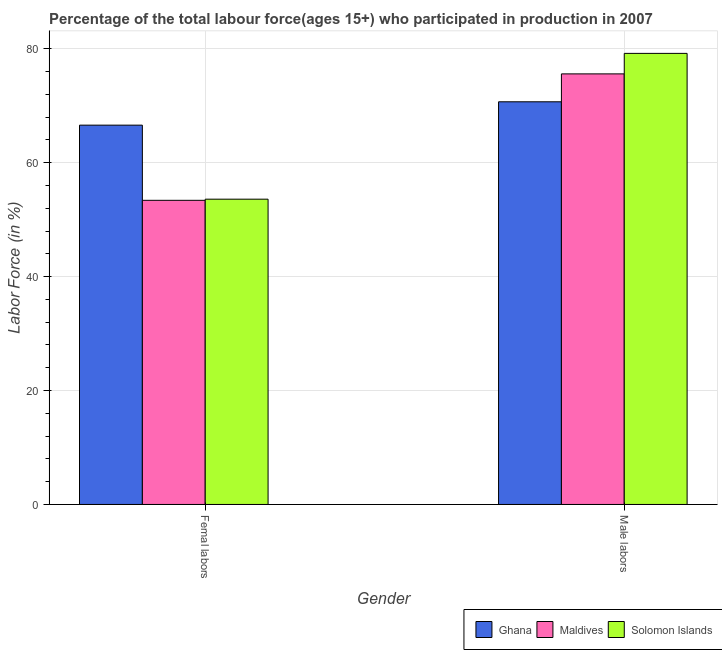Are the number of bars per tick equal to the number of legend labels?
Provide a short and direct response. Yes. How many bars are there on the 2nd tick from the left?
Your response must be concise. 3. What is the label of the 1st group of bars from the left?
Offer a terse response. Femal labors. What is the percentage of male labour force in Solomon Islands?
Your response must be concise. 79.2. Across all countries, what is the maximum percentage of male labour force?
Provide a succinct answer. 79.2. Across all countries, what is the minimum percentage of female labor force?
Your answer should be compact. 53.4. In which country was the percentage of female labor force maximum?
Provide a short and direct response. Ghana. What is the total percentage of male labour force in the graph?
Your response must be concise. 225.5. What is the difference between the percentage of female labor force in Ghana and that in Solomon Islands?
Ensure brevity in your answer.  13. What is the difference between the percentage of male labour force in Ghana and the percentage of female labor force in Maldives?
Provide a short and direct response. 17.3. What is the average percentage of male labour force per country?
Ensure brevity in your answer.  75.17. What is the difference between the percentage of male labour force and percentage of female labor force in Maldives?
Your response must be concise. 22.2. What is the ratio of the percentage of female labor force in Solomon Islands to that in Maldives?
Make the answer very short. 1. In how many countries, is the percentage of female labor force greater than the average percentage of female labor force taken over all countries?
Keep it short and to the point. 1. What does the 2nd bar from the right in Femal labors represents?
Make the answer very short. Maldives. Are all the bars in the graph horizontal?
Ensure brevity in your answer.  No. Does the graph contain grids?
Your response must be concise. Yes. Where does the legend appear in the graph?
Offer a very short reply. Bottom right. How many legend labels are there?
Keep it short and to the point. 3. How are the legend labels stacked?
Ensure brevity in your answer.  Horizontal. What is the title of the graph?
Your answer should be compact. Percentage of the total labour force(ages 15+) who participated in production in 2007. What is the label or title of the X-axis?
Give a very brief answer. Gender. What is the Labor Force (in %) of Ghana in Femal labors?
Your response must be concise. 66.6. What is the Labor Force (in %) of Maldives in Femal labors?
Your answer should be very brief. 53.4. What is the Labor Force (in %) of Solomon Islands in Femal labors?
Your answer should be very brief. 53.6. What is the Labor Force (in %) in Ghana in Male labors?
Provide a short and direct response. 70.7. What is the Labor Force (in %) of Maldives in Male labors?
Your answer should be very brief. 75.6. What is the Labor Force (in %) in Solomon Islands in Male labors?
Make the answer very short. 79.2. Across all Gender, what is the maximum Labor Force (in %) in Ghana?
Offer a terse response. 70.7. Across all Gender, what is the maximum Labor Force (in %) in Maldives?
Provide a succinct answer. 75.6. Across all Gender, what is the maximum Labor Force (in %) in Solomon Islands?
Provide a short and direct response. 79.2. Across all Gender, what is the minimum Labor Force (in %) of Ghana?
Provide a succinct answer. 66.6. Across all Gender, what is the minimum Labor Force (in %) of Maldives?
Offer a terse response. 53.4. Across all Gender, what is the minimum Labor Force (in %) of Solomon Islands?
Provide a short and direct response. 53.6. What is the total Labor Force (in %) of Ghana in the graph?
Give a very brief answer. 137.3. What is the total Labor Force (in %) of Maldives in the graph?
Make the answer very short. 129. What is the total Labor Force (in %) in Solomon Islands in the graph?
Make the answer very short. 132.8. What is the difference between the Labor Force (in %) of Ghana in Femal labors and that in Male labors?
Make the answer very short. -4.1. What is the difference between the Labor Force (in %) in Maldives in Femal labors and that in Male labors?
Offer a terse response. -22.2. What is the difference between the Labor Force (in %) of Solomon Islands in Femal labors and that in Male labors?
Provide a short and direct response. -25.6. What is the difference between the Labor Force (in %) of Ghana in Femal labors and the Labor Force (in %) of Maldives in Male labors?
Your answer should be compact. -9. What is the difference between the Labor Force (in %) in Maldives in Femal labors and the Labor Force (in %) in Solomon Islands in Male labors?
Your response must be concise. -25.8. What is the average Labor Force (in %) in Ghana per Gender?
Provide a short and direct response. 68.65. What is the average Labor Force (in %) of Maldives per Gender?
Keep it short and to the point. 64.5. What is the average Labor Force (in %) in Solomon Islands per Gender?
Ensure brevity in your answer.  66.4. What is the difference between the Labor Force (in %) of Ghana and Labor Force (in %) of Maldives in Femal labors?
Your answer should be compact. 13.2. What is the difference between the Labor Force (in %) in Ghana and Labor Force (in %) in Solomon Islands in Femal labors?
Provide a succinct answer. 13. What is the difference between the Labor Force (in %) in Maldives and Labor Force (in %) in Solomon Islands in Femal labors?
Provide a succinct answer. -0.2. What is the difference between the Labor Force (in %) of Ghana and Labor Force (in %) of Maldives in Male labors?
Keep it short and to the point. -4.9. What is the ratio of the Labor Force (in %) of Ghana in Femal labors to that in Male labors?
Provide a succinct answer. 0.94. What is the ratio of the Labor Force (in %) of Maldives in Femal labors to that in Male labors?
Make the answer very short. 0.71. What is the ratio of the Labor Force (in %) of Solomon Islands in Femal labors to that in Male labors?
Your response must be concise. 0.68. What is the difference between the highest and the second highest Labor Force (in %) in Ghana?
Your answer should be compact. 4.1. What is the difference between the highest and the second highest Labor Force (in %) in Maldives?
Your answer should be very brief. 22.2. What is the difference between the highest and the second highest Labor Force (in %) in Solomon Islands?
Make the answer very short. 25.6. What is the difference between the highest and the lowest Labor Force (in %) of Ghana?
Offer a very short reply. 4.1. What is the difference between the highest and the lowest Labor Force (in %) in Solomon Islands?
Provide a succinct answer. 25.6. 